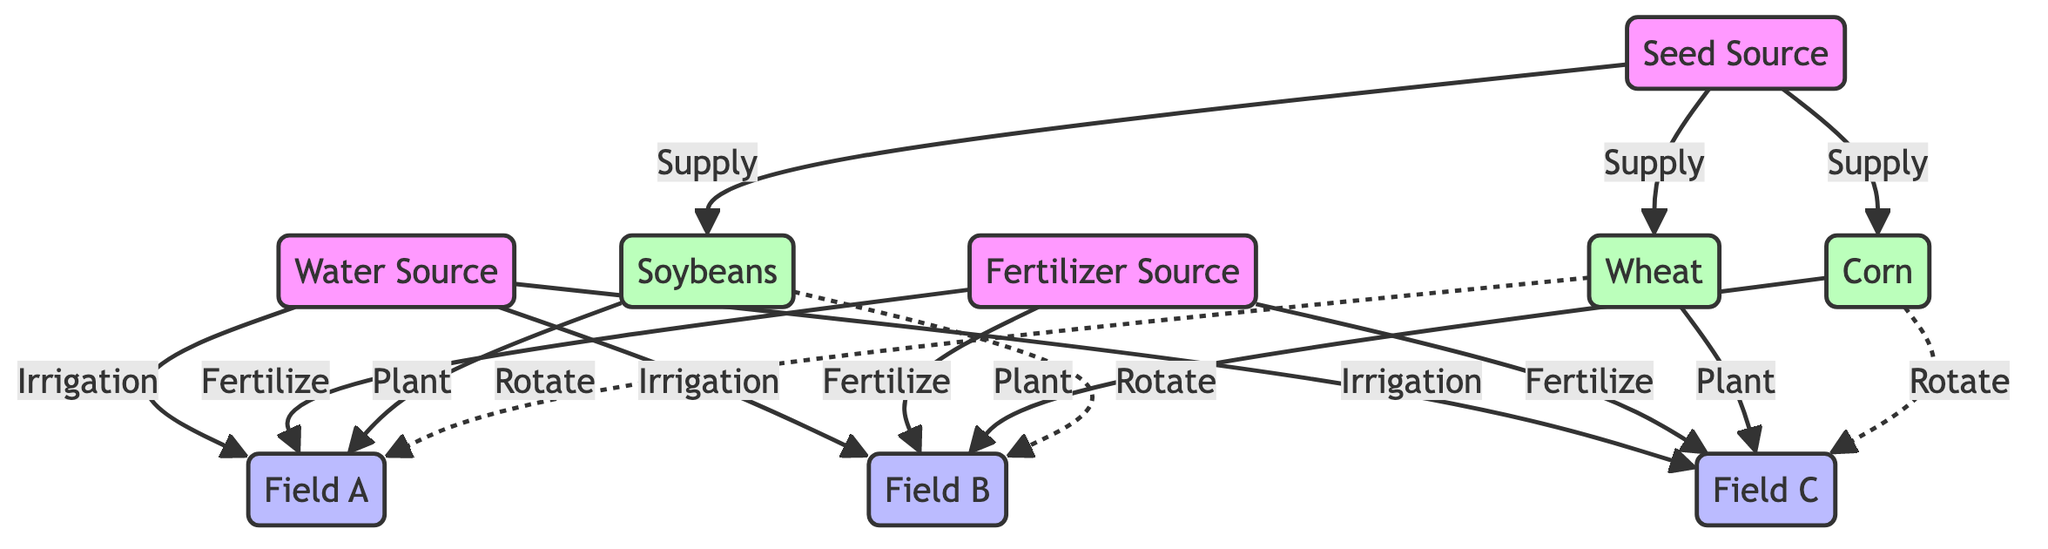What are the three seed types sourced from Seed Source? The diagram clearly shows that the Seed Source supplies three types of seeds: Soybeans, Corn, and Wheat. This is indicated by the edges connecting Seed Source to each of these crop nodes labeled as "Supply".
Answer: Soybeans, Corn, Wheat How many fields are represented in the diagram? The diagram includes three distinct fields labeled Field A, Field B, and Field C. These are identified as nodes connected to the Water Source and Fertilizer Source, indicating they are the target locations for irrigation and fertilization.
Answer: 3 Which crop is planted in Field B? According to the diagram, the crop assigned to Field B is Corn, as indicated by the "Plant" edge from the Corn node to Field B. This connection specifies that Corn is cultivated specifically in that field.
Answer: Corn What is the relationship between Soybeans and Field B? The diagram shows a dashed line labeled "Rotate" from the Soybeans node to Field B. This indicates that the relationship involves crop rotation, meaning that Soybeans can be shifted to Field B after the appropriate cycle.
Answer: Rotate Which field receives irrigation from Water Source? All three fields (Field A, Field B, and Field C) are connected to the Water Source through "Irrigation" edges. This means that each field receives water supply for crop growth.
Answer: Field A, Field B, Field C What is the common action linked to the Fertilizer Source? The common action associated with the Fertilizer Source, as seen in the diagram, is "Fertilize". Each edge leading from the Fertilizer Source to the fields is labeled with this action, indicating that all fields receive fertilization from this source.
Answer: Fertilize Which crop is rotated into Field A? The diagram indicates that Wheat is rotated into Field A, as shown by the dashed "Rotate" edge connecting Wheat to Field A. This means that after farming in Field A, Wheat will be the next crop grown there.
Answer: Wheat How many supply connections are there from the Seed Source? The Seed Source provides supply connections to three crop types: Soybeans, Corn, and Wheat, as indicated by three edges labeled "Supply". Thus, there are a total of three supply connections.
Answer: 3 